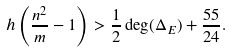<formula> <loc_0><loc_0><loc_500><loc_500>h \left ( \frac { n ^ { 2 } } { m } - 1 \right ) > \frac { 1 } { 2 } \deg ( \Delta _ { E } ) + \frac { 5 5 } { 2 4 } .</formula> 